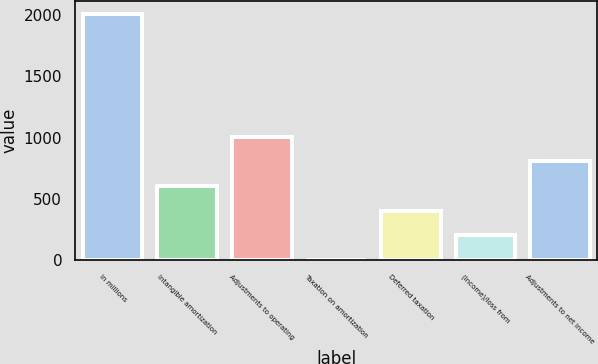Convert chart. <chart><loc_0><loc_0><loc_500><loc_500><bar_chart><fcel>in millions<fcel>Intangible amortization<fcel>Adjustments to operating<fcel>Taxation on amortization<fcel>Deferred taxation<fcel>(Income)/loss from<fcel>Adjustments to net income<nl><fcel>2011<fcel>606.38<fcel>1007.7<fcel>4.4<fcel>405.72<fcel>205.06<fcel>807.04<nl></chart> 